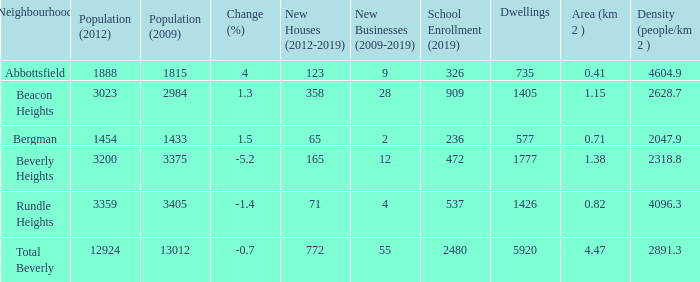Calculate the density for an area of 1.38 km with a population greater than 12,924. 0.0. 